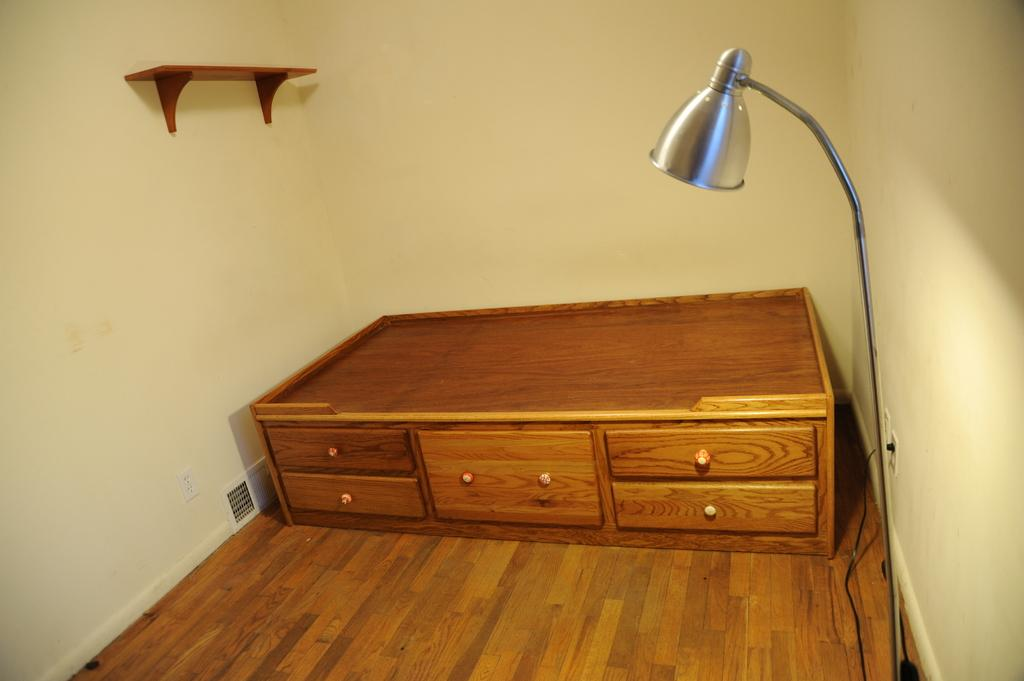What type of furniture is present in the image? There is a desk in the image. Are there any other objects related to lighting in the image? Yes, there is a lamp in the image. What type of storage or display feature is present in the image? There is a shelf in the image. What does the mouth of the fowl look like in the image? There is no fowl present in the image, so we cannot describe its mouth. 